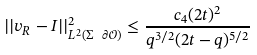Convert formula to latex. <formula><loc_0><loc_0><loc_500><loc_500>| | v _ { R } - I | | ^ { 2 } _ { L ^ { 2 } ( \Sigma \ \partial \mathcal { O } ) } \leq \frac { c _ { 4 } ( 2 t ) ^ { 2 } } { q ^ { 3 / 2 } ( 2 t - q ) ^ { 5 / 2 } }</formula> 